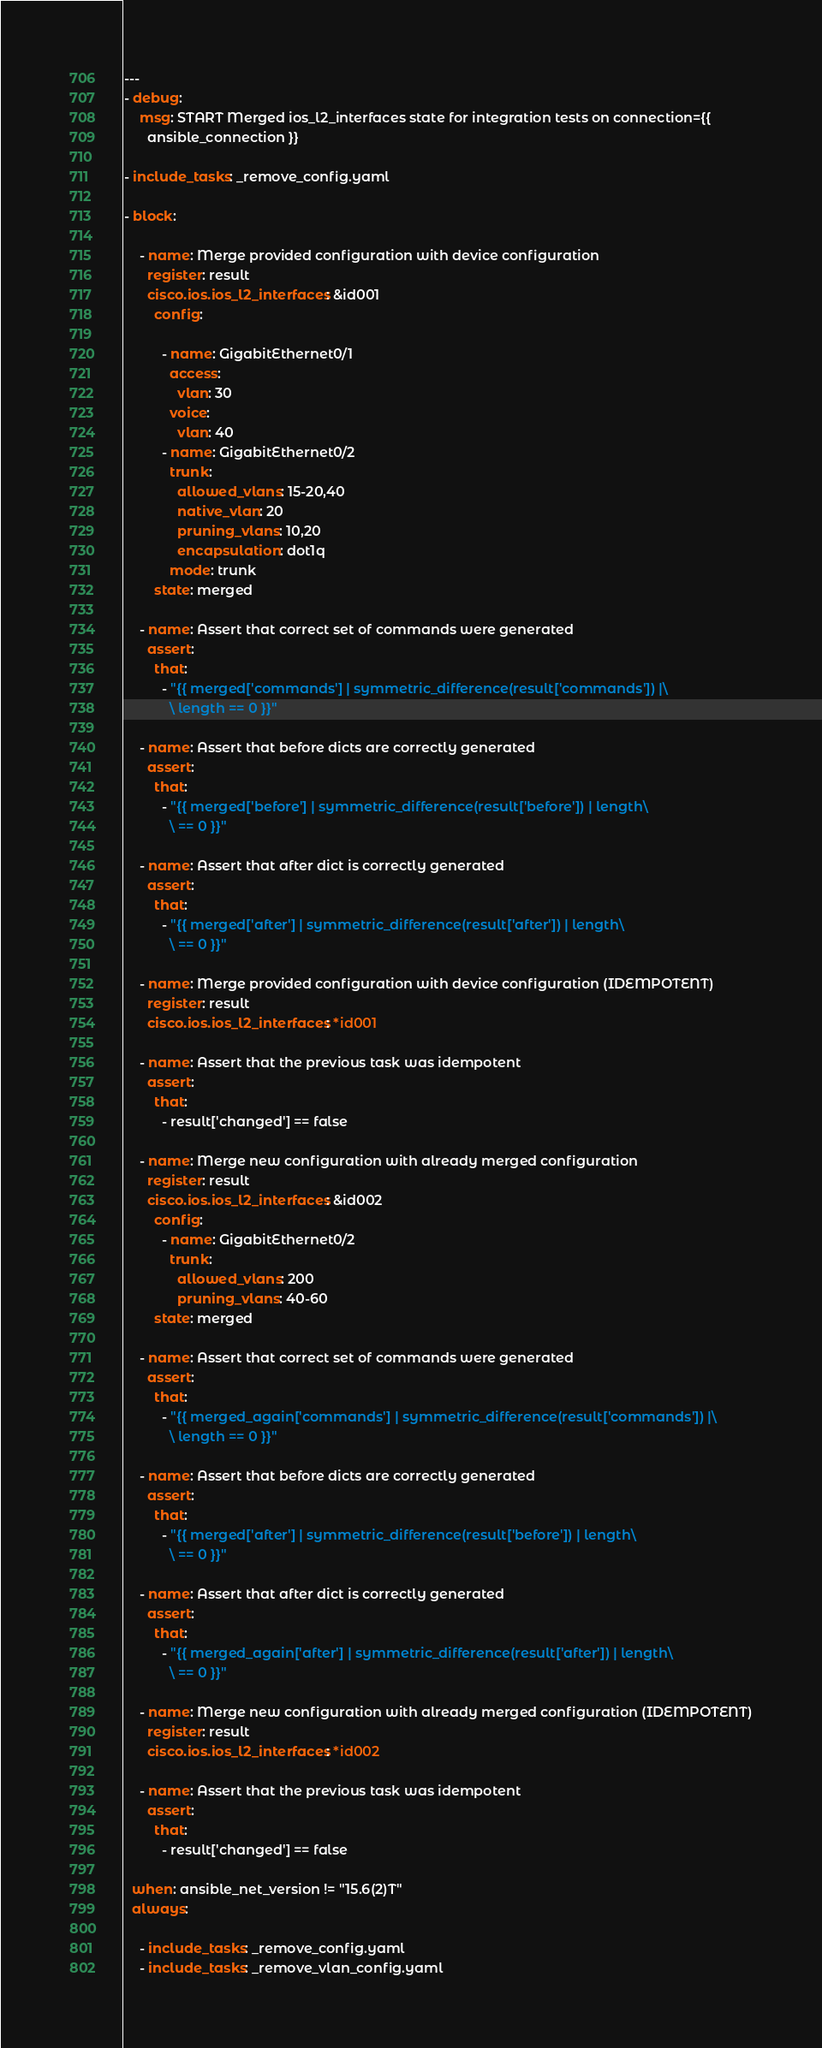Convert code to text. <code><loc_0><loc_0><loc_500><loc_500><_YAML_>---
- debug:
    msg: START Merged ios_l2_interfaces state for integration tests on connection={{
      ansible_connection }}

- include_tasks: _remove_config.yaml

- block:

    - name: Merge provided configuration with device configuration
      register: result
      cisco.ios.ios_l2_interfaces: &id001
        config:

          - name: GigabitEthernet0/1
            access:
              vlan: 30
            voice:
              vlan: 40
          - name: GigabitEthernet0/2
            trunk:
              allowed_vlans: 15-20,40
              native_vlan: 20
              pruning_vlans: 10,20
              encapsulation: dot1q
            mode: trunk
        state: merged

    - name: Assert that correct set of commands were generated
      assert:
        that:
          - "{{ merged['commands'] | symmetric_difference(result['commands']) |\
            \ length == 0 }}"

    - name: Assert that before dicts are correctly generated
      assert:
        that:
          - "{{ merged['before'] | symmetric_difference(result['before']) | length\
            \ == 0 }}"

    - name: Assert that after dict is correctly generated
      assert:
        that:
          - "{{ merged['after'] | symmetric_difference(result['after']) | length\
            \ == 0 }}"

    - name: Merge provided configuration with device configuration (IDEMPOTENT)
      register: result
      cisco.ios.ios_l2_interfaces: *id001

    - name: Assert that the previous task was idempotent
      assert:
        that:
          - result['changed'] == false

    - name: Merge new configuration with already merged configuration
      register: result
      cisco.ios.ios_l2_interfaces: &id002
        config:
          - name: GigabitEthernet0/2
            trunk:
              allowed_vlans: 200
              pruning_vlans: 40-60
        state: merged

    - name: Assert that correct set of commands were generated
      assert:
        that:
          - "{{ merged_again['commands'] | symmetric_difference(result['commands']) |\
            \ length == 0 }}"

    - name: Assert that before dicts are correctly generated
      assert:
        that:
          - "{{ merged['after'] | symmetric_difference(result['before']) | length\
            \ == 0 }}"

    - name: Assert that after dict is correctly generated
      assert:
        that:
          - "{{ merged_again['after'] | symmetric_difference(result['after']) | length\
            \ == 0 }}"

    - name: Merge new configuration with already merged configuration (IDEMPOTENT)
      register: result
      cisco.ios.ios_l2_interfaces: *id002

    - name: Assert that the previous task was idempotent
      assert:
        that:
          - result['changed'] == false

  when: ansible_net_version != "15.6(2)T"
  always:

    - include_tasks: _remove_config.yaml
    - include_tasks: _remove_vlan_config.yaml
</code> 